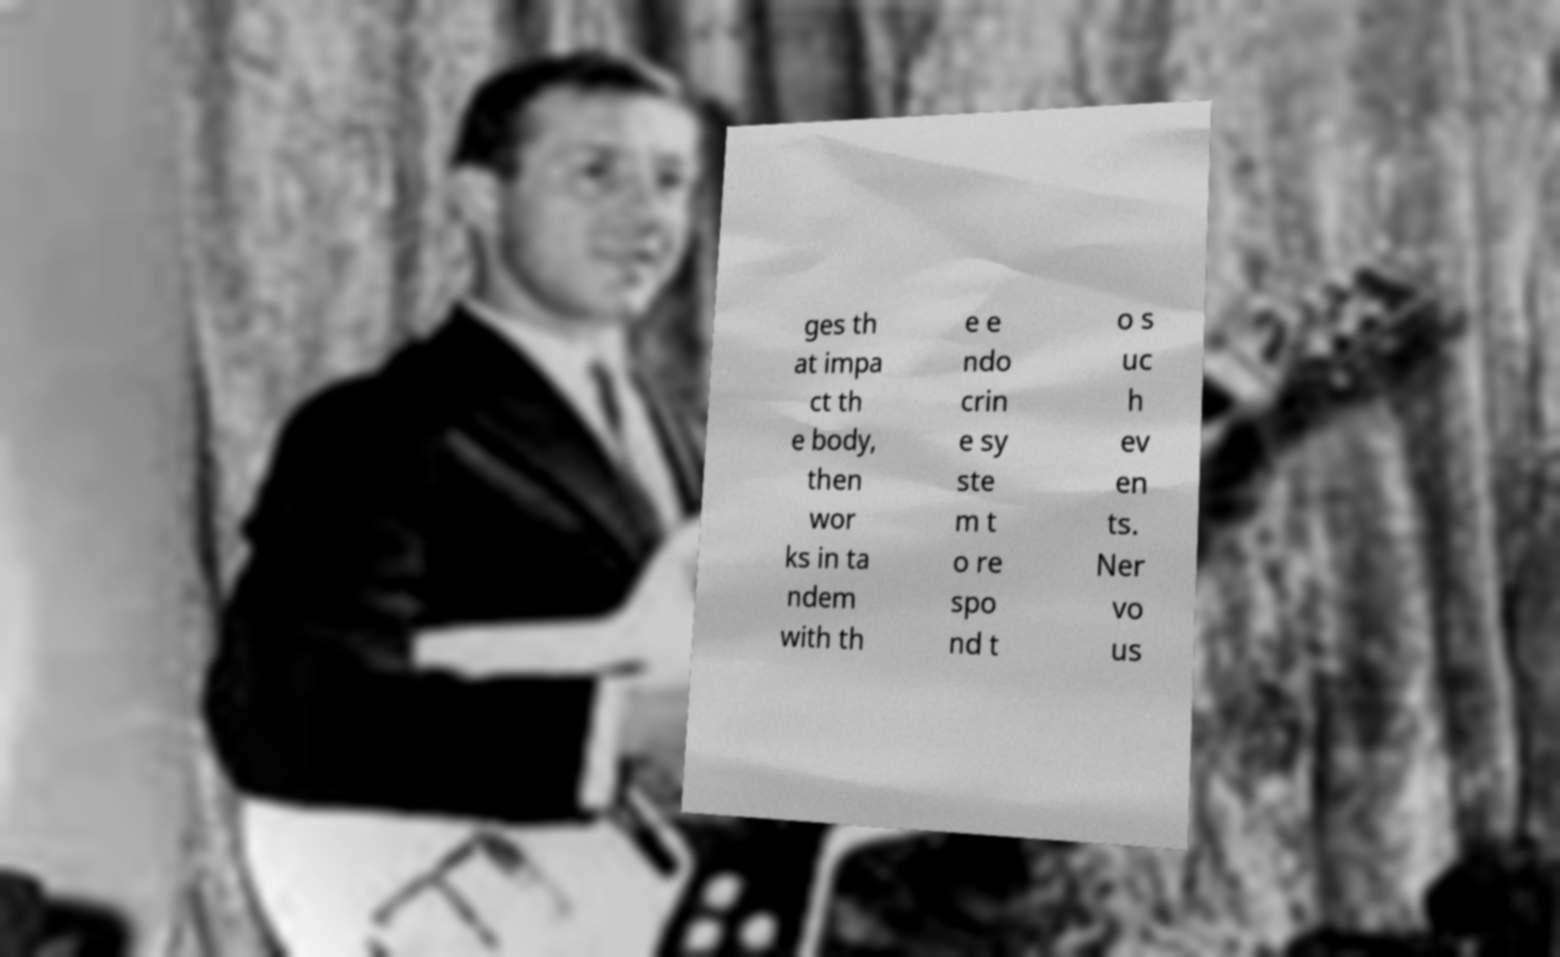Can you accurately transcribe the text from the provided image for me? ges th at impa ct th e body, then wor ks in ta ndem with th e e ndo crin e sy ste m t o re spo nd t o s uc h ev en ts. Ner vo us 